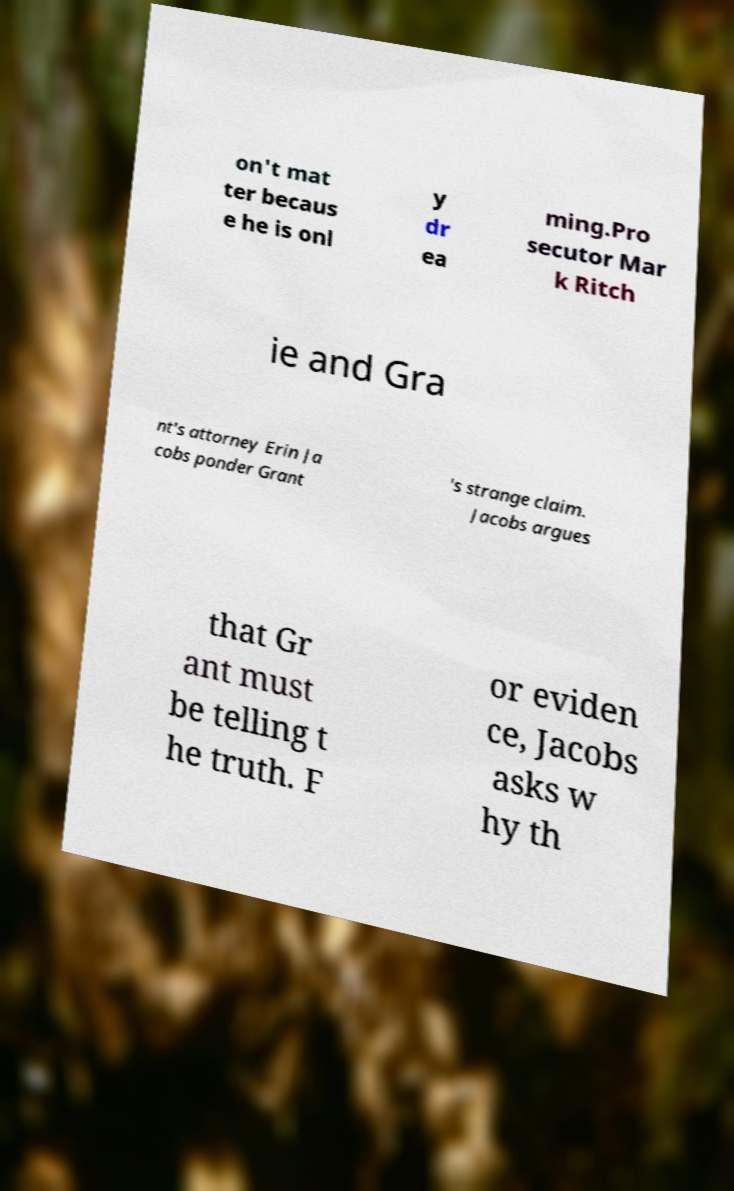What messages or text are displayed in this image? I need them in a readable, typed format. on't mat ter becaus e he is onl y dr ea ming.Pro secutor Mar k Ritch ie and Gra nt's attorney Erin Ja cobs ponder Grant 's strange claim. Jacobs argues that Gr ant must be telling t he truth. F or eviden ce, Jacobs asks w hy th 